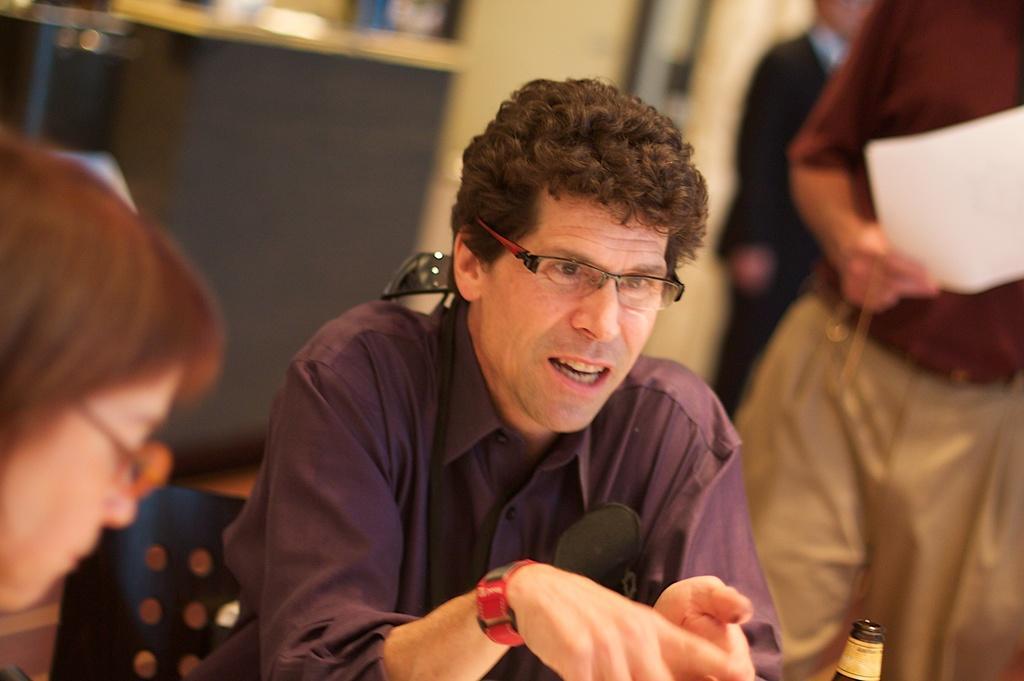In one or two sentences, can you explain what this image depicts? In this image I can see a group of people, chairs, table, wall and photo frames. This image is taken may be in a hall. 